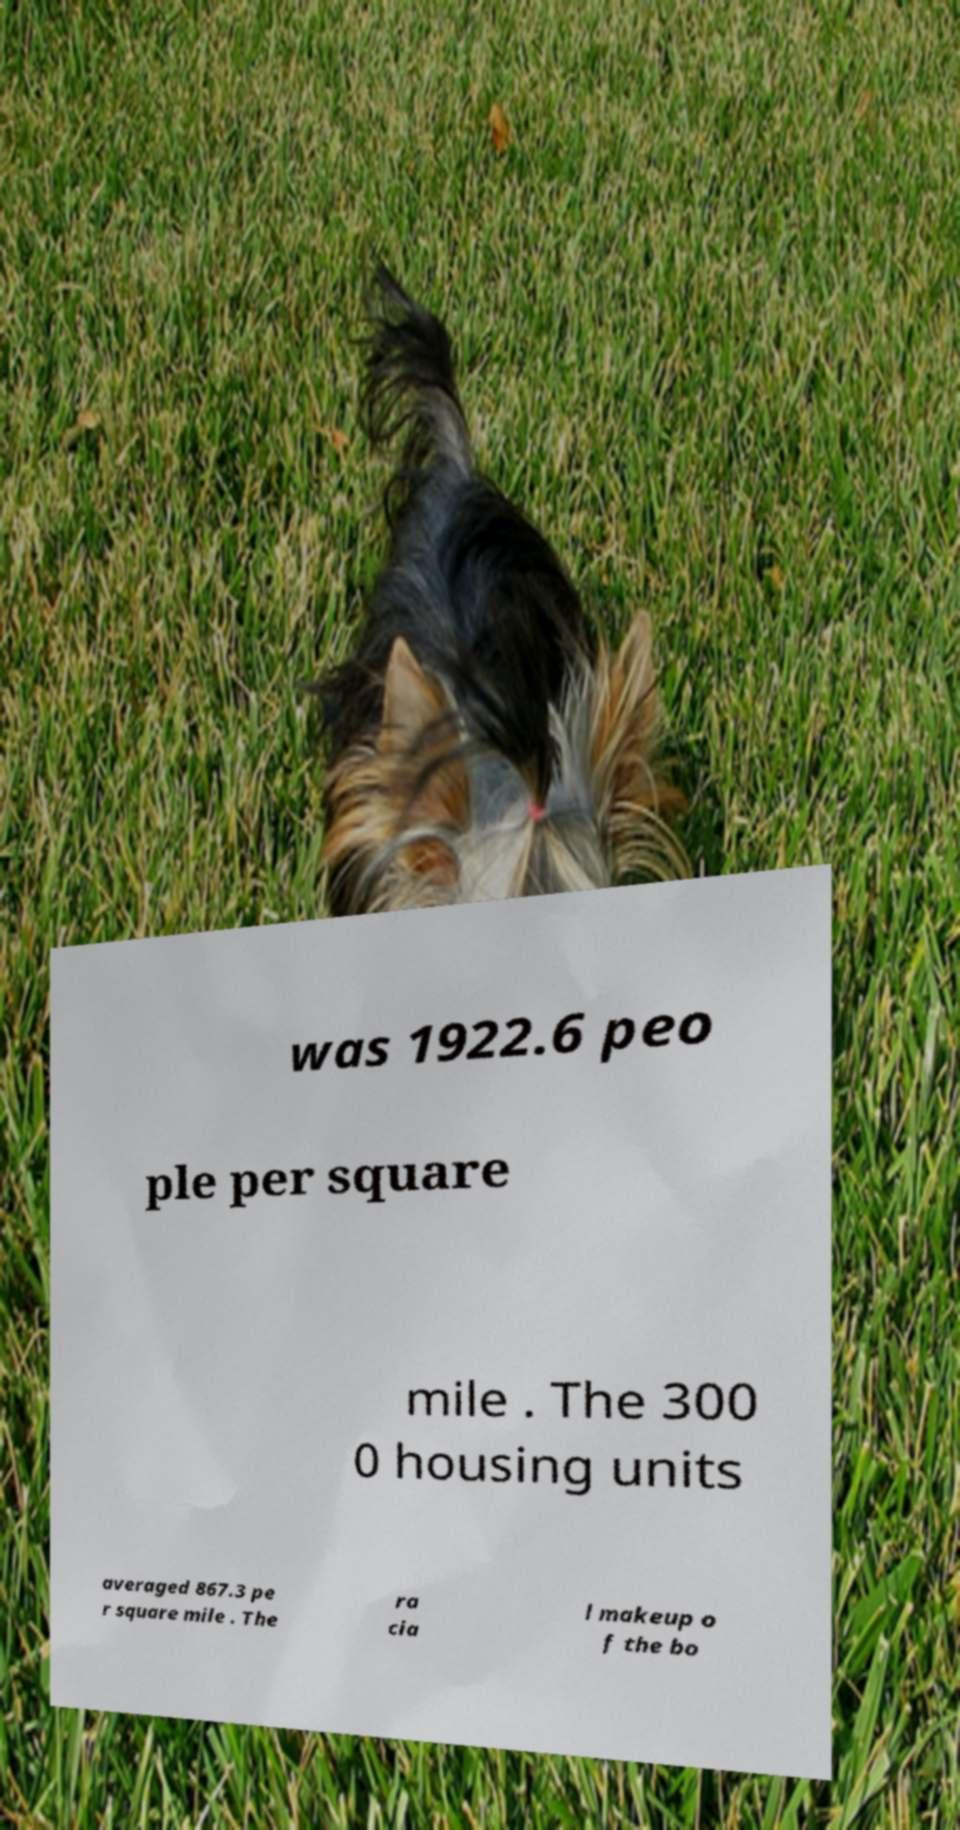Can you read and provide the text displayed in the image?This photo seems to have some interesting text. Can you extract and type it out for me? was 1922.6 peo ple per square mile . The 300 0 housing units averaged 867.3 pe r square mile . The ra cia l makeup o f the bo 